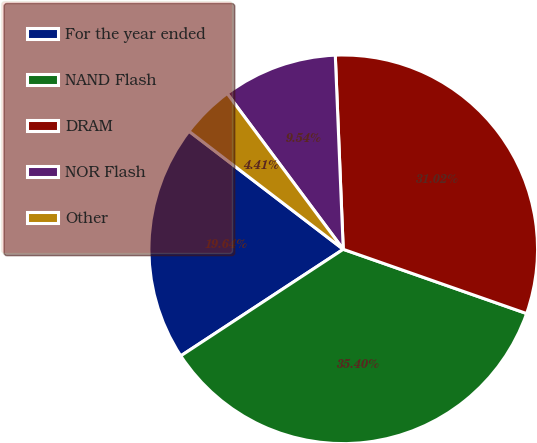Convert chart to OTSL. <chart><loc_0><loc_0><loc_500><loc_500><pie_chart><fcel>For the year ended<fcel>NAND Flash<fcel>DRAM<fcel>NOR Flash<fcel>Other<nl><fcel>19.64%<fcel>35.4%<fcel>31.02%<fcel>9.54%<fcel>4.41%<nl></chart> 